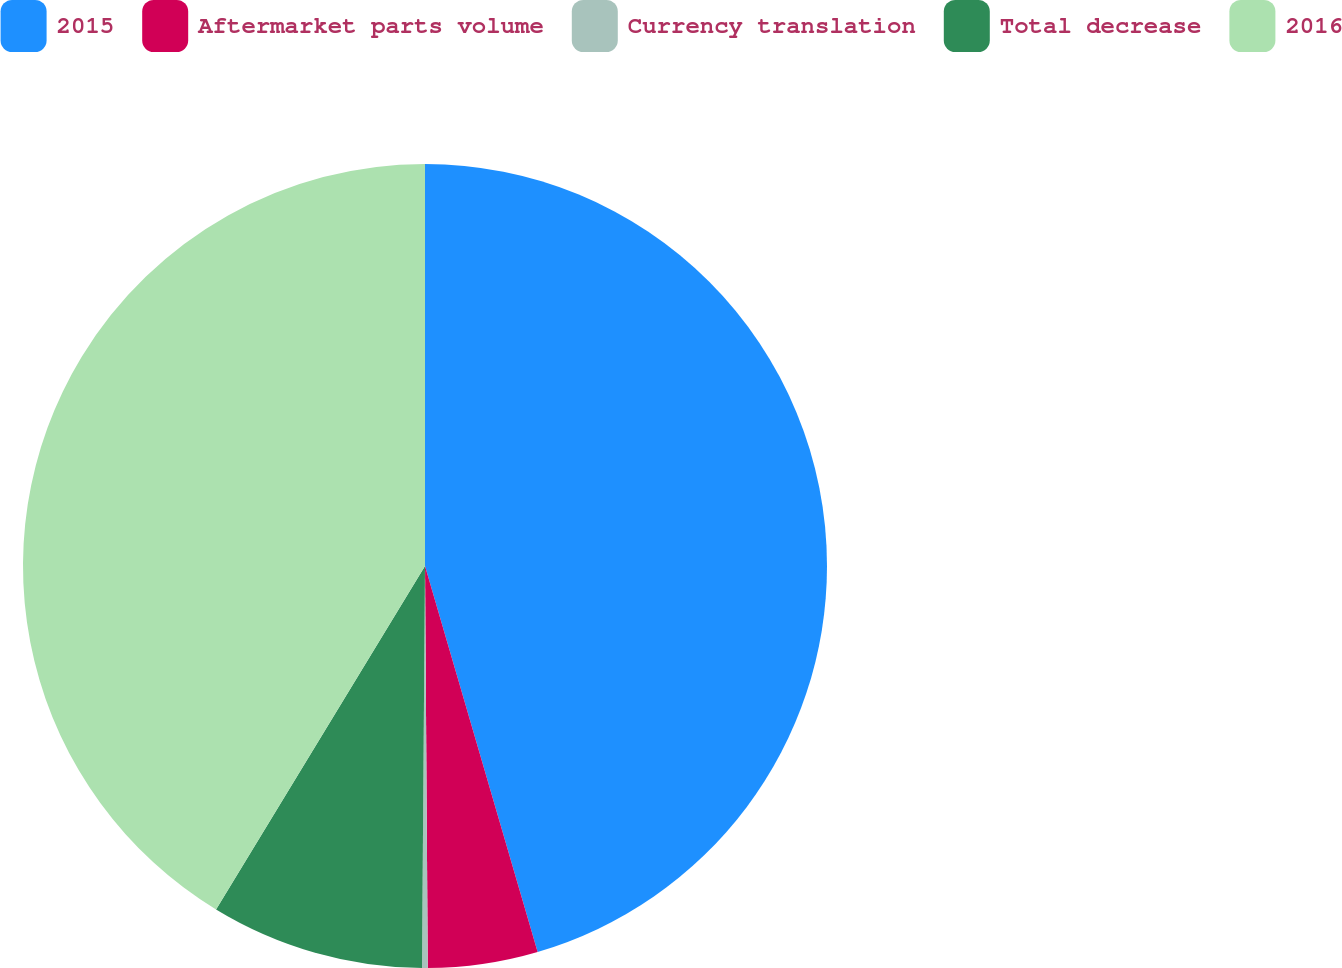<chart> <loc_0><loc_0><loc_500><loc_500><pie_chart><fcel>2015<fcel>Aftermarket parts volume<fcel>Currency translation<fcel>Total decrease<fcel>2016<nl><fcel>45.48%<fcel>4.41%<fcel>0.23%<fcel>8.58%<fcel>41.3%<nl></chart> 